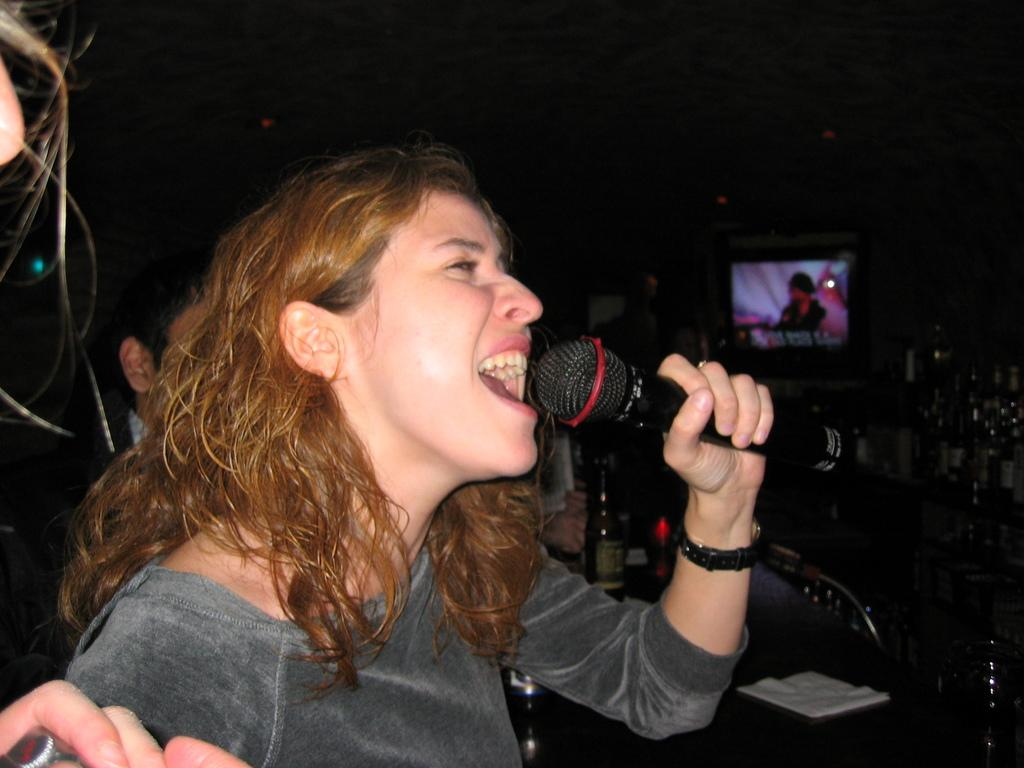How many people are in the image? There are people in the image, but the exact number is not specified. What is the woman doing in the image? A woman is singing with the help of a microphone in the image. What else can be seen in the image besides the people and the woman singing? There is a bottle and a television visible in the image. What type of flowers are being used as a centerpiece for the meal in the image? There is no mention of flowers or a meal in the image; it features people, a woman singing with a microphone, a bottle, and a television. 